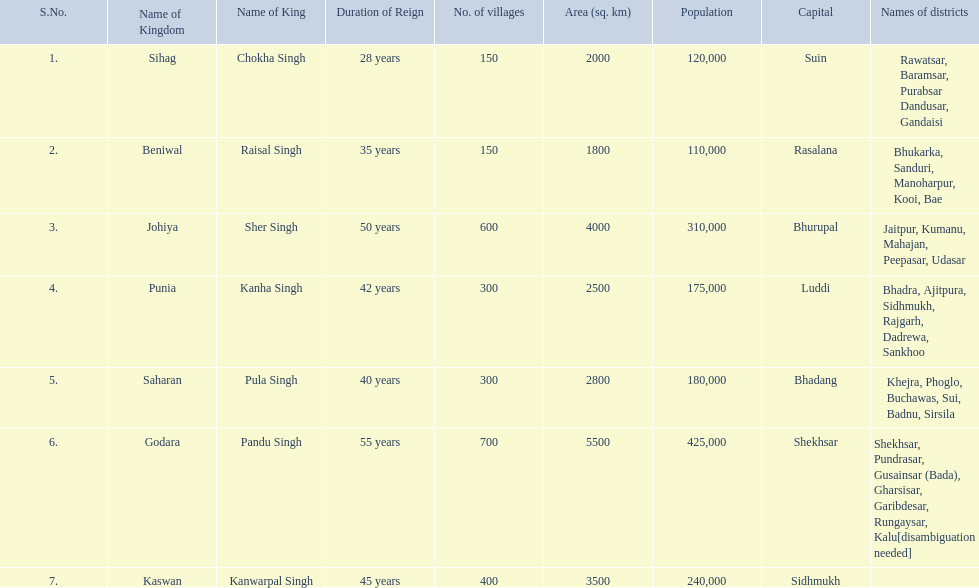What are the number of villages johiya has according to this chart? 600. 